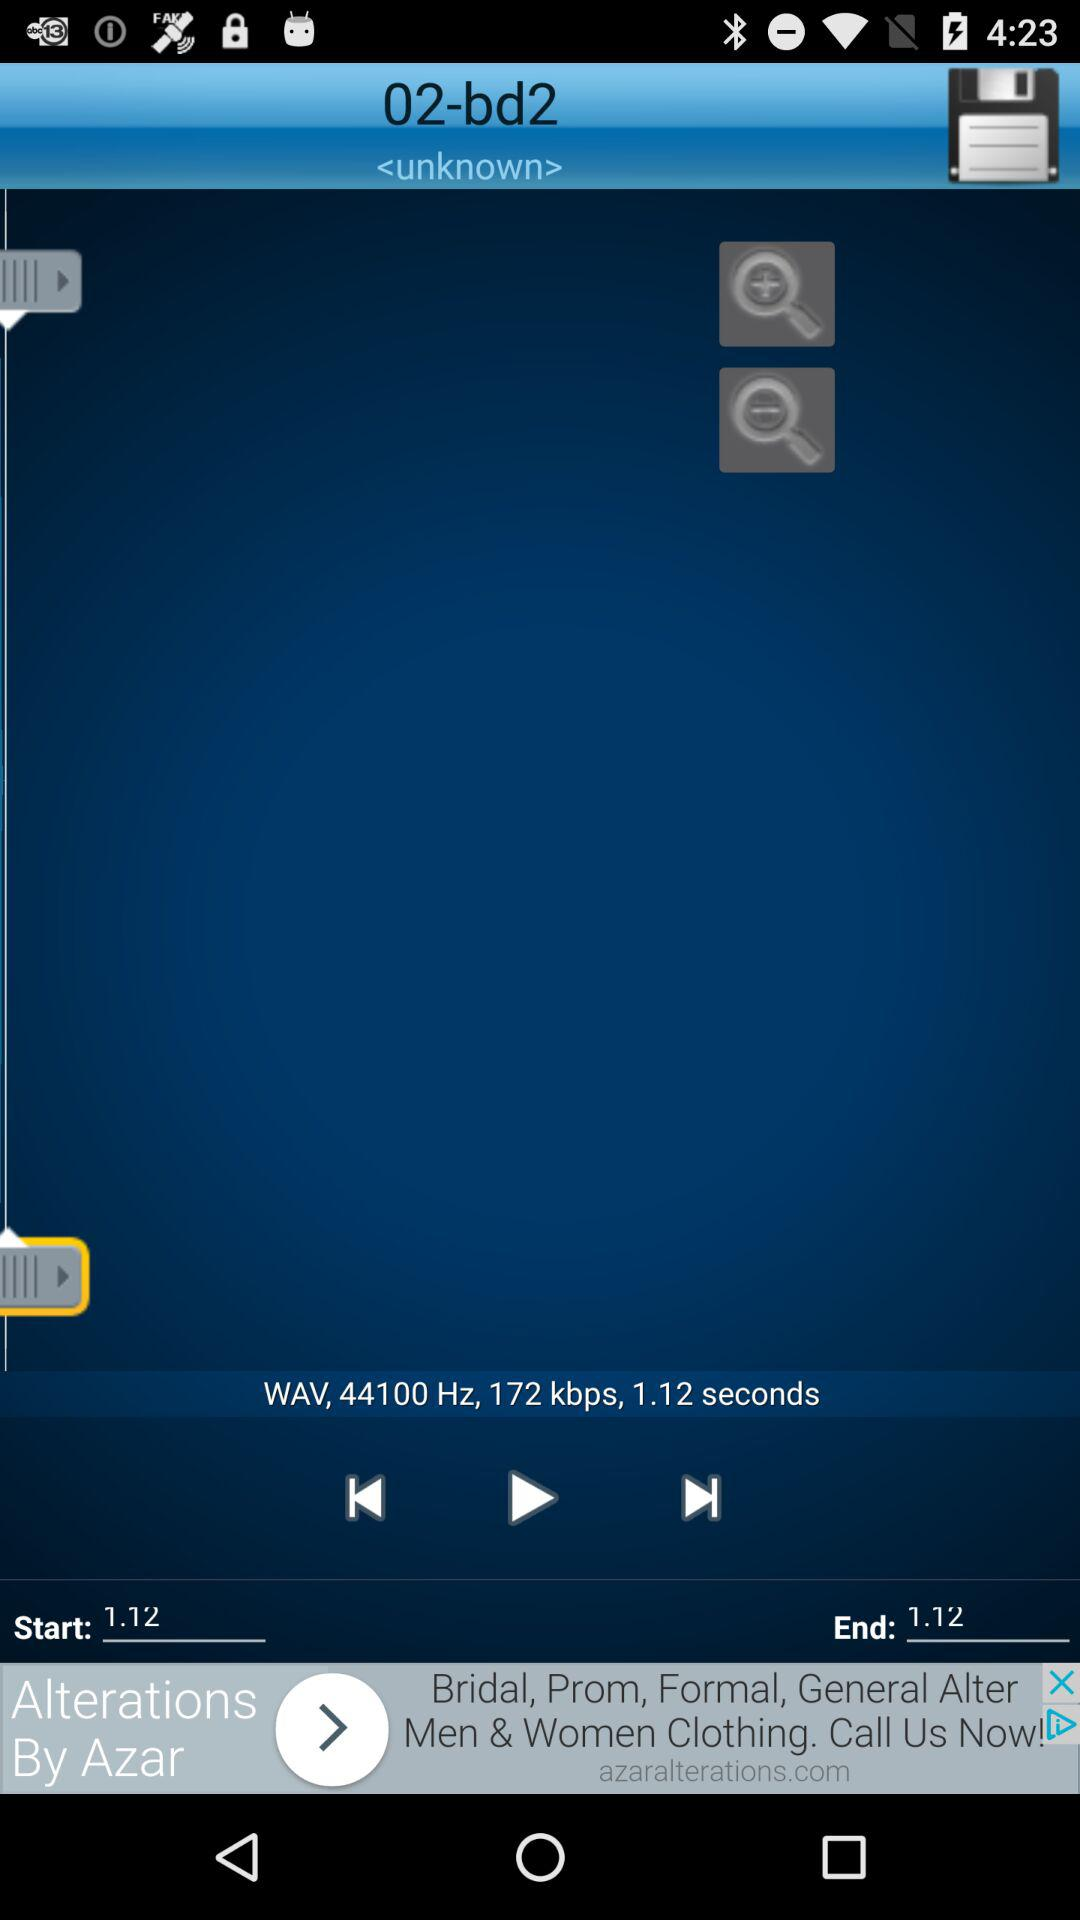What is the start time? The start time is 1.12. 